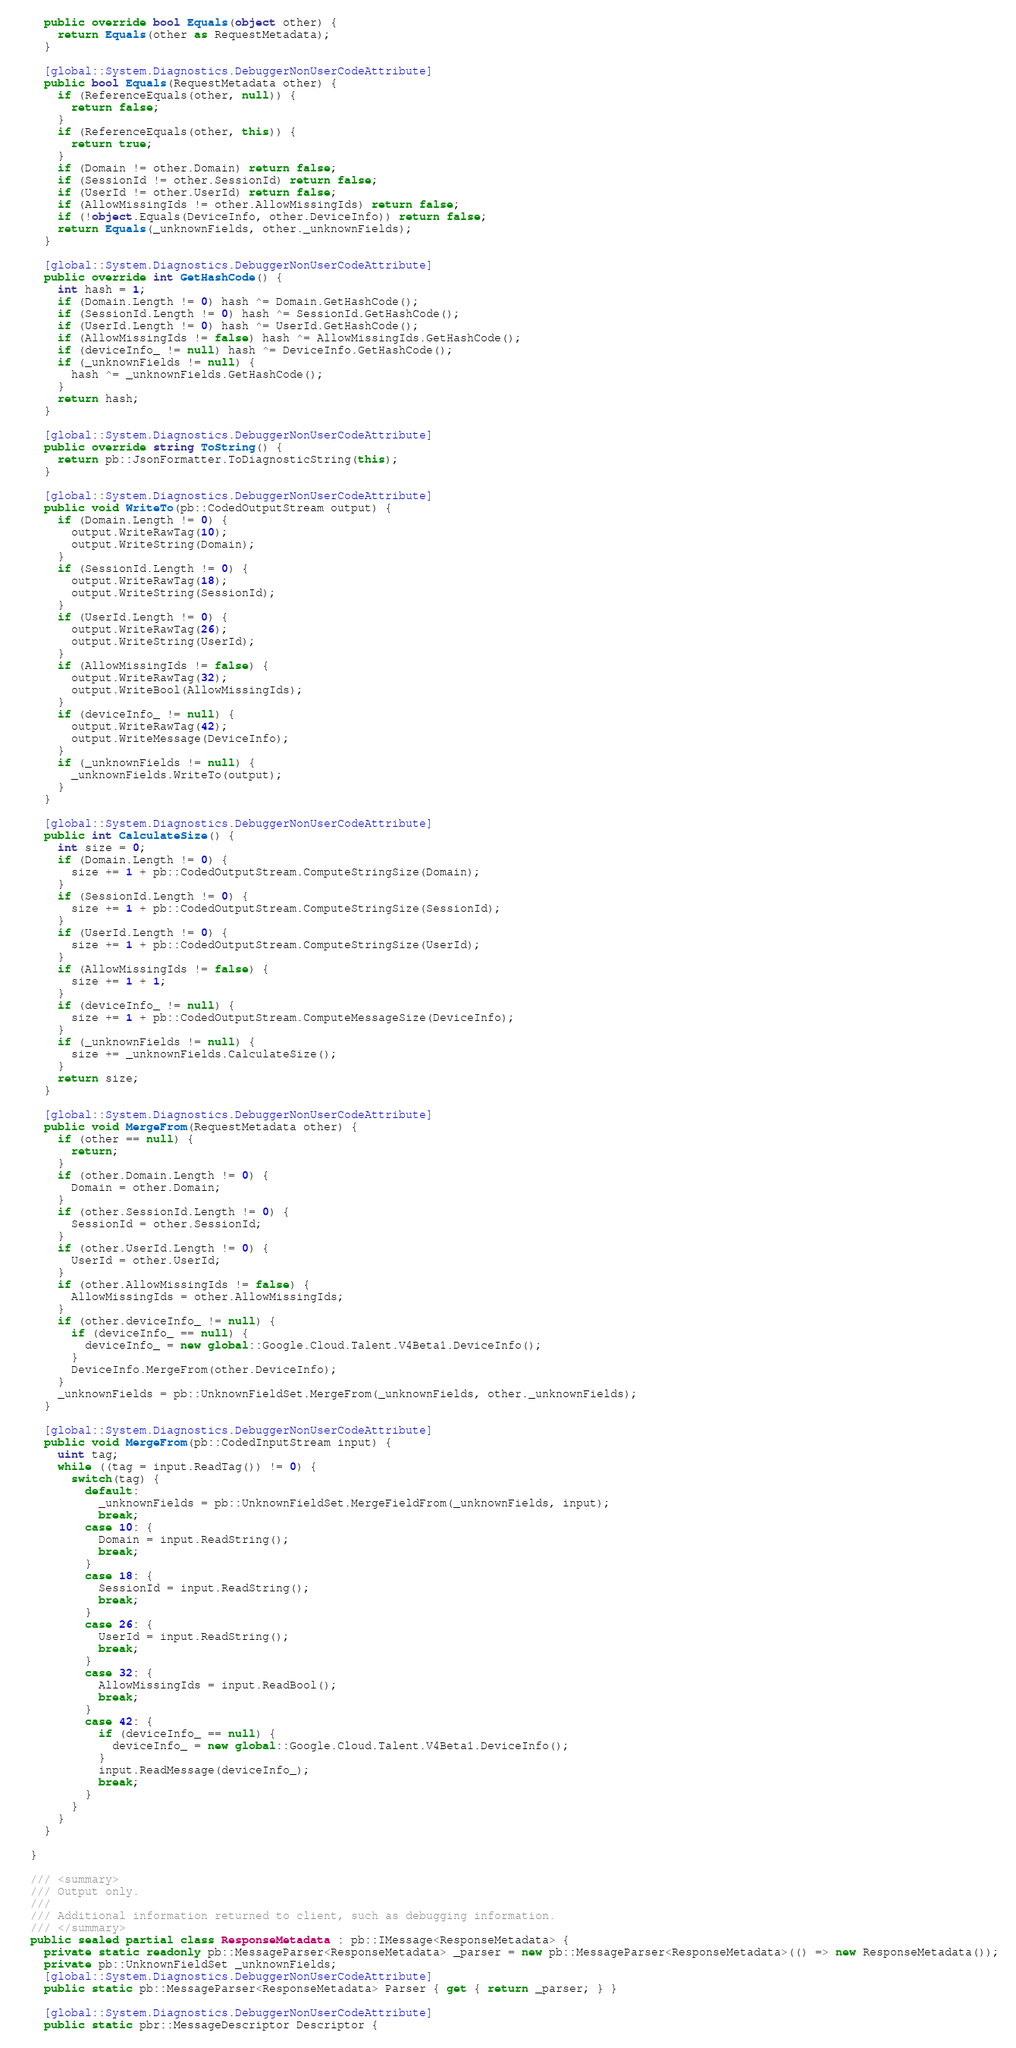<code> <loc_0><loc_0><loc_500><loc_500><_C#_>    public override bool Equals(object other) {
      return Equals(other as RequestMetadata);
    }

    [global::System.Diagnostics.DebuggerNonUserCodeAttribute]
    public bool Equals(RequestMetadata other) {
      if (ReferenceEquals(other, null)) {
        return false;
      }
      if (ReferenceEquals(other, this)) {
        return true;
      }
      if (Domain != other.Domain) return false;
      if (SessionId != other.SessionId) return false;
      if (UserId != other.UserId) return false;
      if (AllowMissingIds != other.AllowMissingIds) return false;
      if (!object.Equals(DeviceInfo, other.DeviceInfo)) return false;
      return Equals(_unknownFields, other._unknownFields);
    }

    [global::System.Diagnostics.DebuggerNonUserCodeAttribute]
    public override int GetHashCode() {
      int hash = 1;
      if (Domain.Length != 0) hash ^= Domain.GetHashCode();
      if (SessionId.Length != 0) hash ^= SessionId.GetHashCode();
      if (UserId.Length != 0) hash ^= UserId.GetHashCode();
      if (AllowMissingIds != false) hash ^= AllowMissingIds.GetHashCode();
      if (deviceInfo_ != null) hash ^= DeviceInfo.GetHashCode();
      if (_unknownFields != null) {
        hash ^= _unknownFields.GetHashCode();
      }
      return hash;
    }

    [global::System.Diagnostics.DebuggerNonUserCodeAttribute]
    public override string ToString() {
      return pb::JsonFormatter.ToDiagnosticString(this);
    }

    [global::System.Diagnostics.DebuggerNonUserCodeAttribute]
    public void WriteTo(pb::CodedOutputStream output) {
      if (Domain.Length != 0) {
        output.WriteRawTag(10);
        output.WriteString(Domain);
      }
      if (SessionId.Length != 0) {
        output.WriteRawTag(18);
        output.WriteString(SessionId);
      }
      if (UserId.Length != 0) {
        output.WriteRawTag(26);
        output.WriteString(UserId);
      }
      if (AllowMissingIds != false) {
        output.WriteRawTag(32);
        output.WriteBool(AllowMissingIds);
      }
      if (deviceInfo_ != null) {
        output.WriteRawTag(42);
        output.WriteMessage(DeviceInfo);
      }
      if (_unknownFields != null) {
        _unknownFields.WriteTo(output);
      }
    }

    [global::System.Diagnostics.DebuggerNonUserCodeAttribute]
    public int CalculateSize() {
      int size = 0;
      if (Domain.Length != 0) {
        size += 1 + pb::CodedOutputStream.ComputeStringSize(Domain);
      }
      if (SessionId.Length != 0) {
        size += 1 + pb::CodedOutputStream.ComputeStringSize(SessionId);
      }
      if (UserId.Length != 0) {
        size += 1 + pb::CodedOutputStream.ComputeStringSize(UserId);
      }
      if (AllowMissingIds != false) {
        size += 1 + 1;
      }
      if (deviceInfo_ != null) {
        size += 1 + pb::CodedOutputStream.ComputeMessageSize(DeviceInfo);
      }
      if (_unknownFields != null) {
        size += _unknownFields.CalculateSize();
      }
      return size;
    }

    [global::System.Diagnostics.DebuggerNonUserCodeAttribute]
    public void MergeFrom(RequestMetadata other) {
      if (other == null) {
        return;
      }
      if (other.Domain.Length != 0) {
        Domain = other.Domain;
      }
      if (other.SessionId.Length != 0) {
        SessionId = other.SessionId;
      }
      if (other.UserId.Length != 0) {
        UserId = other.UserId;
      }
      if (other.AllowMissingIds != false) {
        AllowMissingIds = other.AllowMissingIds;
      }
      if (other.deviceInfo_ != null) {
        if (deviceInfo_ == null) {
          deviceInfo_ = new global::Google.Cloud.Talent.V4Beta1.DeviceInfo();
        }
        DeviceInfo.MergeFrom(other.DeviceInfo);
      }
      _unknownFields = pb::UnknownFieldSet.MergeFrom(_unknownFields, other._unknownFields);
    }

    [global::System.Diagnostics.DebuggerNonUserCodeAttribute]
    public void MergeFrom(pb::CodedInputStream input) {
      uint tag;
      while ((tag = input.ReadTag()) != 0) {
        switch(tag) {
          default:
            _unknownFields = pb::UnknownFieldSet.MergeFieldFrom(_unknownFields, input);
            break;
          case 10: {
            Domain = input.ReadString();
            break;
          }
          case 18: {
            SessionId = input.ReadString();
            break;
          }
          case 26: {
            UserId = input.ReadString();
            break;
          }
          case 32: {
            AllowMissingIds = input.ReadBool();
            break;
          }
          case 42: {
            if (deviceInfo_ == null) {
              deviceInfo_ = new global::Google.Cloud.Talent.V4Beta1.DeviceInfo();
            }
            input.ReadMessage(deviceInfo_);
            break;
          }
        }
      }
    }

  }

  /// <summary>
  /// Output only.
  ///
  /// Additional information returned to client, such as debugging information.
  /// </summary>
  public sealed partial class ResponseMetadata : pb::IMessage<ResponseMetadata> {
    private static readonly pb::MessageParser<ResponseMetadata> _parser = new pb::MessageParser<ResponseMetadata>(() => new ResponseMetadata());
    private pb::UnknownFieldSet _unknownFields;
    [global::System.Diagnostics.DebuggerNonUserCodeAttribute]
    public static pb::MessageParser<ResponseMetadata> Parser { get { return _parser; } }

    [global::System.Diagnostics.DebuggerNonUserCodeAttribute]
    public static pbr::MessageDescriptor Descriptor {</code> 